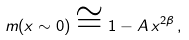Convert formula to latex. <formula><loc_0><loc_0><loc_500><loc_500>m ( x \sim 0 ) \cong 1 - A \, x ^ { 2 \beta } \, ,</formula> 